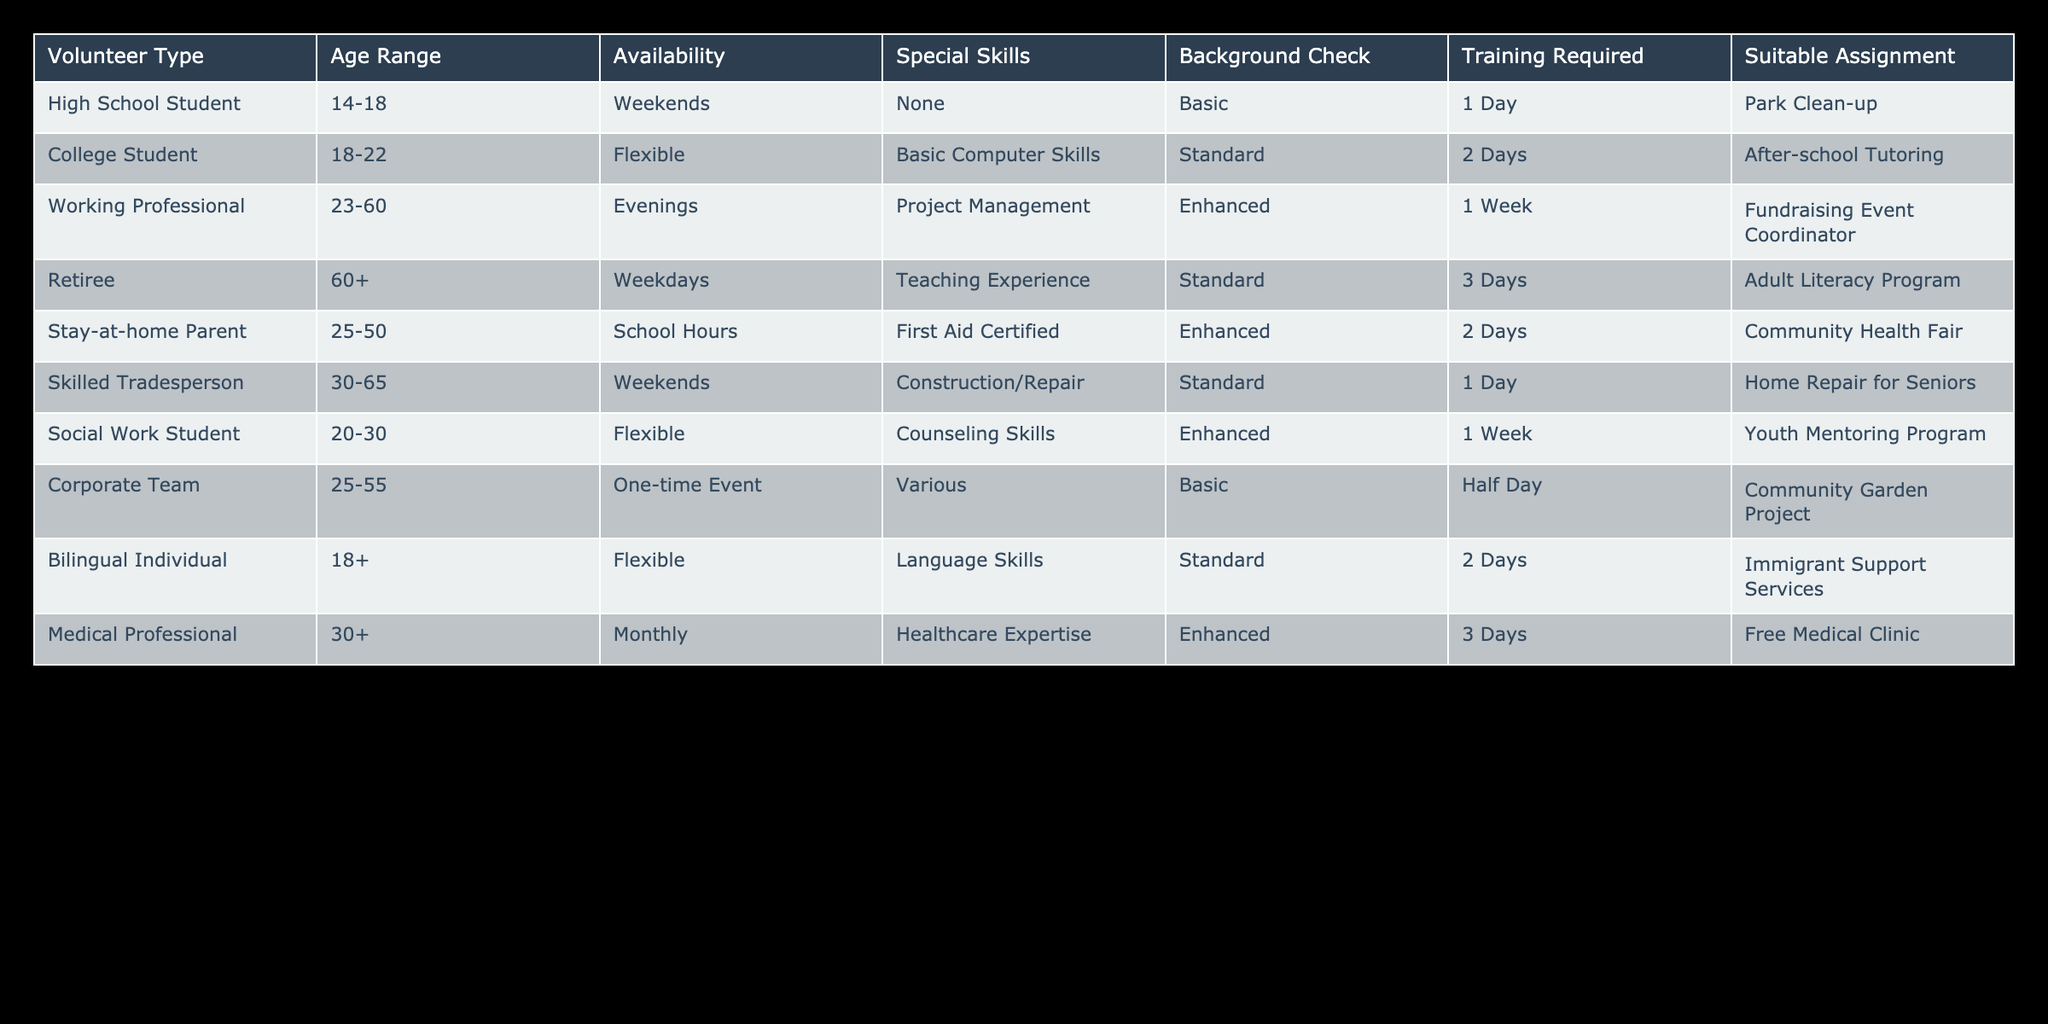What type of volunteer is suited for the Park Clean-up assignment? The table indicates that the suitable assignment for a High School Student is Park Clean-up. This can be found in the "Suitable Assignment" column under the corresponding "Volunteer Type" entry.
Answer: High School Student Which volunteers can work on weekends? Referring to the "Availability" column, the following volunteer types can work on weekends: High School Student, Skilled Tradesperson. Thus, there are two types of volunteers available for weekend assignments.
Answer: 2 Is a background check required for the Community Health Fair assignment? From the table, the assignment for Community Health Fair requires a stay-at-home parent, who is categorized under "Enhanced" for the background check. Therefore, yes, a background check is required for this assignment.
Answer: Yes What is the minimum age of volunteers who can assist in the Adult Literacy Program? The Adult Literacy Program suitable assignment is for retirees, who belong to the age range of 60 and older. This information can be found in the "Age Range" column corresponding to the "Retiree" entry.
Answer: 60+ Which volunteer type requires the most training days? Analyzing the "Training Required" column, the maximum training days noted are 3 days for two volunteer types: Retiree and Medical Professional. Looking specifically for the volunteer type, both require the same amount of training time.
Answer: Retiree and Medical Professional For those available on school hours, what special skills should they have? The only volunteer type that is available during school hours is the stay-at-home parent, who possesses First Aid Certified special skills. This can be retrieved from the specific entries in the "Availability" and "Special Skills" columns.
Answer: First Aid Certified What is the total number of different volunteer assignments listed in the table? The table lists a total of 10 unique volunteer assignments when examining the "Suitable Assignment" column and ensuring no duplicates are present. This can be quickly counted by listing them individually as seen in the table.
Answer: 10 Are there volunteers specializing in healthcare expertise who work monthly? The table shows that the Medical Professional has expertise in healthcare and is available to volunteer on a monthly basis, confirming the presence of such volunteers specializing in this domain.
Answer: Yes Which volunteer type has the most required training days after the Retiree? After Retiree, the next volunteer type that requires training for 3 days is the Medical Professional. This can be found by examining the "Training Required" column and comparing training days for each volunteer type.
Answer: Medical Professional 